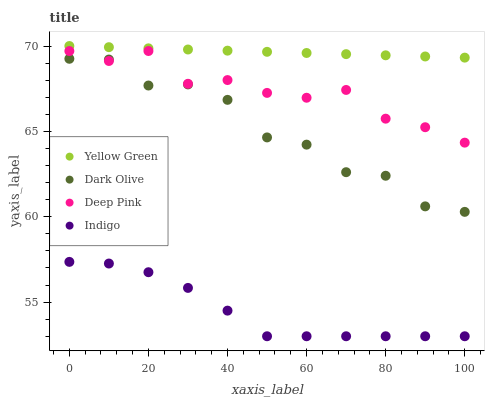Does Indigo have the minimum area under the curve?
Answer yes or no. Yes. Does Yellow Green have the maximum area under the curve?
Answer yes or no. Yes. Does Yellow Green have the minimum area under the curve?
Answer yes or no. No. Does Indigo have the maximum area under the curve?
Answer yes or no. No. Is Yellow Green the smoothest?
Answer yes or no. Yes. Is Dark Olive the roughest?
Answer yes or no. Yes. Is Indigo the smoothest?
Answer yes or no. No. Is Indigo the roughest?
Answer yes or no. No. Does Indigo have the lowest value?
Answer yes or no. Yes. Does Yellow Green have the lowest value?
Answer yes or no. No. Does Yellow Green have the highest value?
Answer yes or no. Yes. Does Indigo have the highest value?
Answer yes or no. No. Is Indigo less than Yellow Green?
Answer yes or no. Yes. Is Yellow Green greater than Deep Pink?
Answer yes or no. Yes. Does Dark Olive intersect Deep Pink?
Answer yes or no. Yes. Is Dark Olive less than Deep Pink?
Answer yes or no. No. Is Dark Olive greater than Deep Pink?
Answer yes or no. No. Does Indigo intersect Yellow Green?
Answer yes or no. No. 